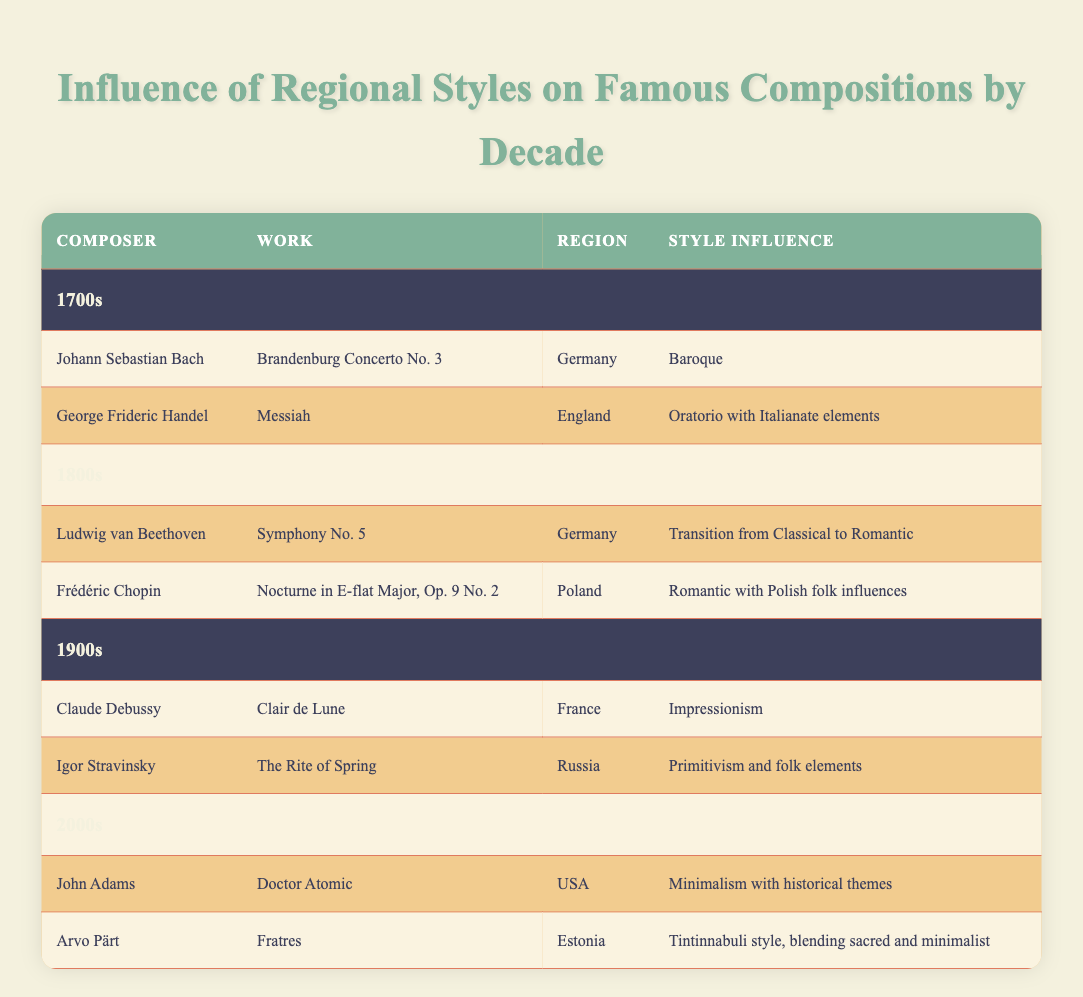What composer is associated with the work "Messiah"? The table lists George Frideric Handel as the composer who created "Messiah." It shows his name in the composer column alongside the corresponding work in the next column.
Answer: George Frideric Handel Which region is associated with "Clair de Lune"? According to the table, "Clair de Lune" is associated with the region of France, as Indicated in the column designated for region next to the work.
Answer: France How many composers from the 1800s wrote works influenced by Romantic style? There are two composers listed from the 1800s: Ludwig van Beethoven with "Symphony No. 5" and Frédéric Chopin with "Nocturne in E-flat Major, Op. 9 No. 2." Both works are influenced by Romantic styles.
Answer: 2 Is "Doctor Atomic" influenced by Baroque style? Based on the information in the table, "Doctor Atomic" is influenced by Minimalism with historical themes, not Baroque style, which is associated with earlier works such as those from the 1700s.
Answer: No What was the predominant style influence for the works listed in the 1700s? Reviewing the table, the two works from the 1700s, "Brandenburg Concerto No. 3" and "Messiah," suggest that Baroque is the predominant style influence during that decade. This is evident as one work is explicitly marked as Baroque while the other has Italianate elements typical of the style.
Answer: Baroque 